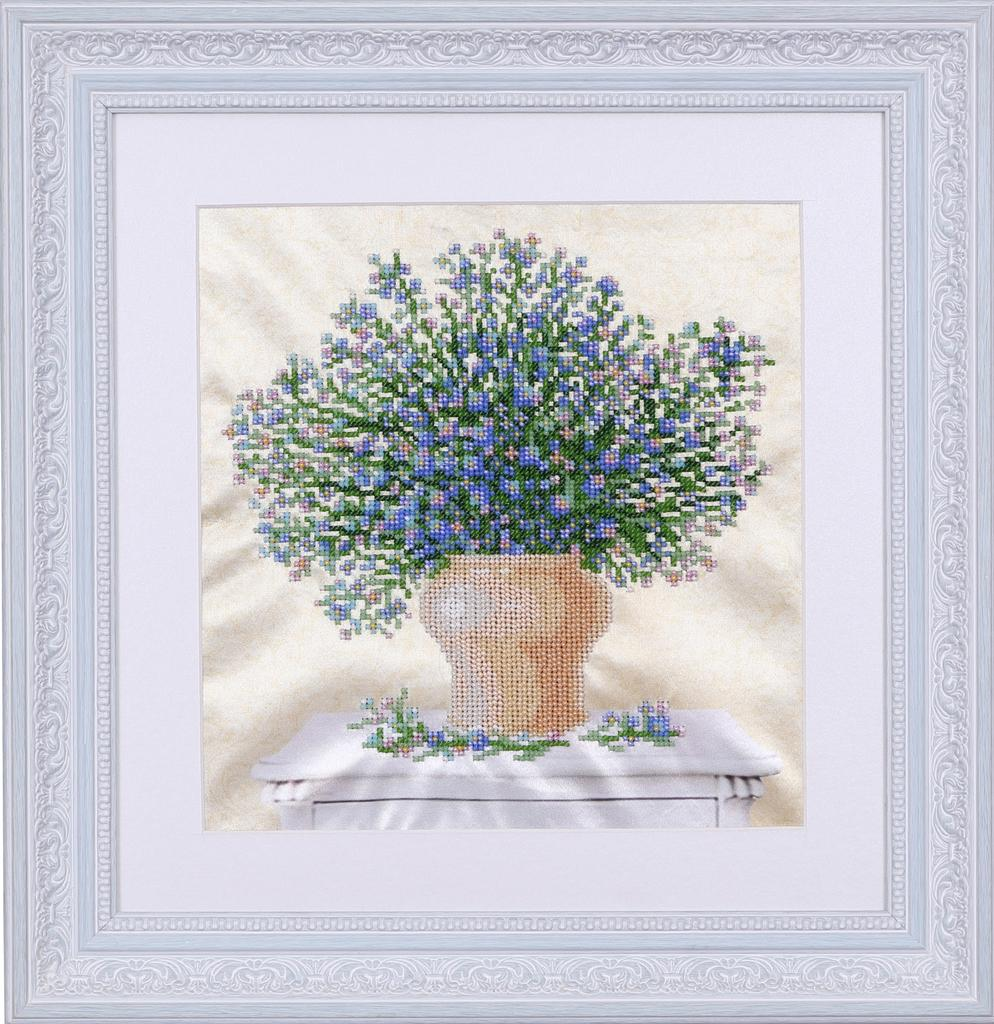What object is present in the image that typically holds a photograph? There is a photo frame in the image. What is inside the photo frame? The photo frame contains a flower vase. Where are the photo frame and flower vase located? The photo frame and flower vase are on a table. Can you see the pear on the table next to the photo frame? There is no pear present in the image; only the photo frame and flower vase are visible on the table. 